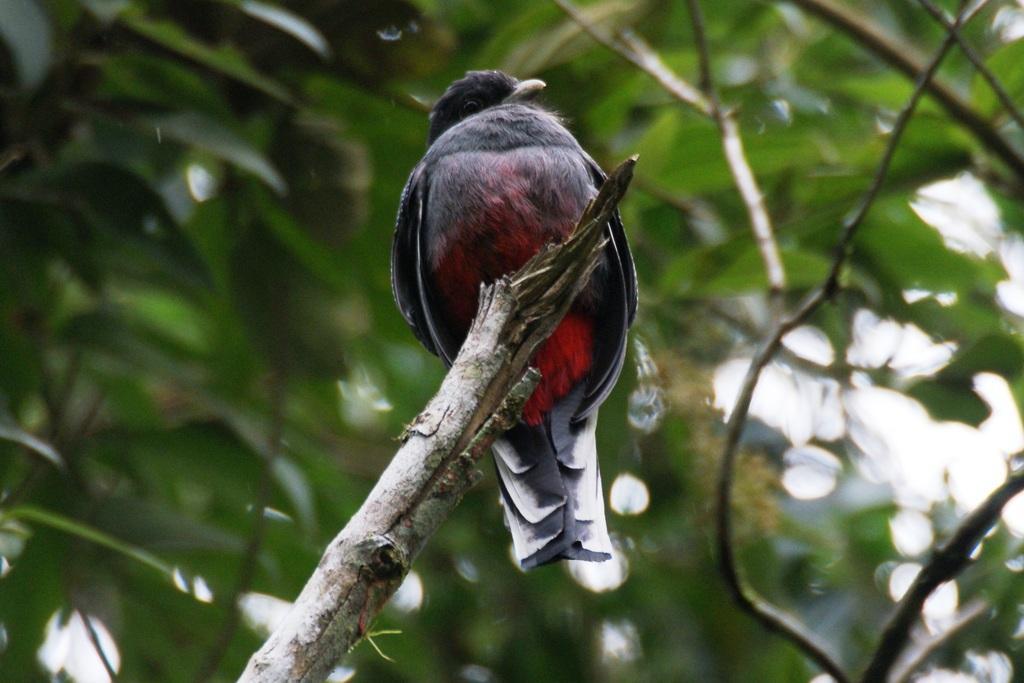Can you describe this image briefly? In the picture we can see a tree stem on it, we can see a bird which is black in color and some under it we can see some red and white in color and behind the bird we can see some plants. 